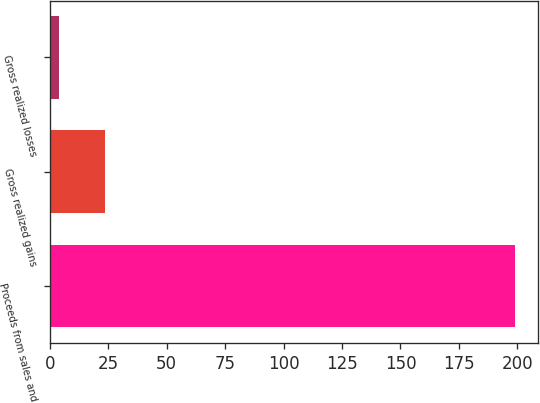Convert chart to OTSL. <chart><loc_0><loc_0><loc_500><loc_500><bar_chart><fcel>Proceeds from sales and<fcel>Gross realized gains<fcel>Gross realized losses<nl><fcel>199<fcel>23.5<fcel>4<nl></chart> 